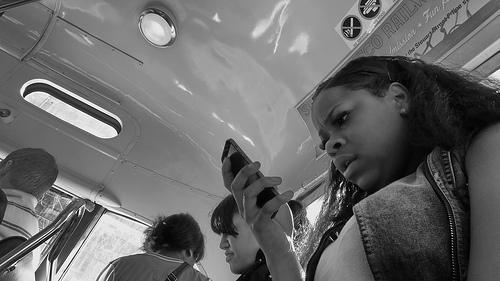How many people are visibly holding a phone?
Give a very brief answer. 1. How many people are visible in this photo?
Give a very brief answer. 4. 